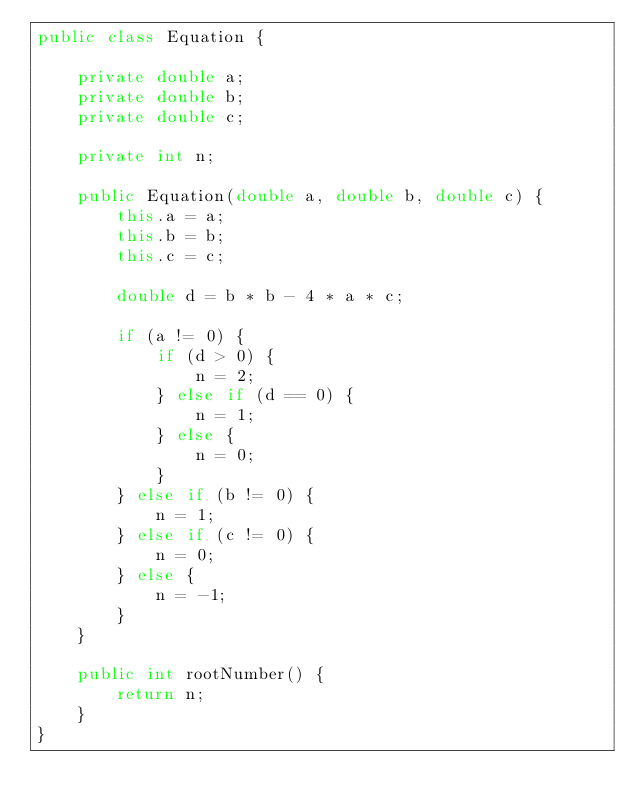<code> <loc_0><loc_0><loc_500><loc_500><_Java_>public class Equation {

    private double a;
    private double b;
    private double c;

    private int n;

    public Equation(double a, double b, double c) {
        this.a = a;
        this.b = b;
        this.c = c;

        double d = b * b - 4 * a * c;

        if (a != 0) {
            if (d > 0) {
                n = 2;
            } else if (d == 0) {
                n = 1;
            } else {
                n = 0;
            }
        } else if (b != 0) {
            n = 1;
        } else if (c != 0) {
            n = 0;
        } else {
            n = -1;
        }
    }

    public int rootNumber() {
        return n;
    }
}
</code> 